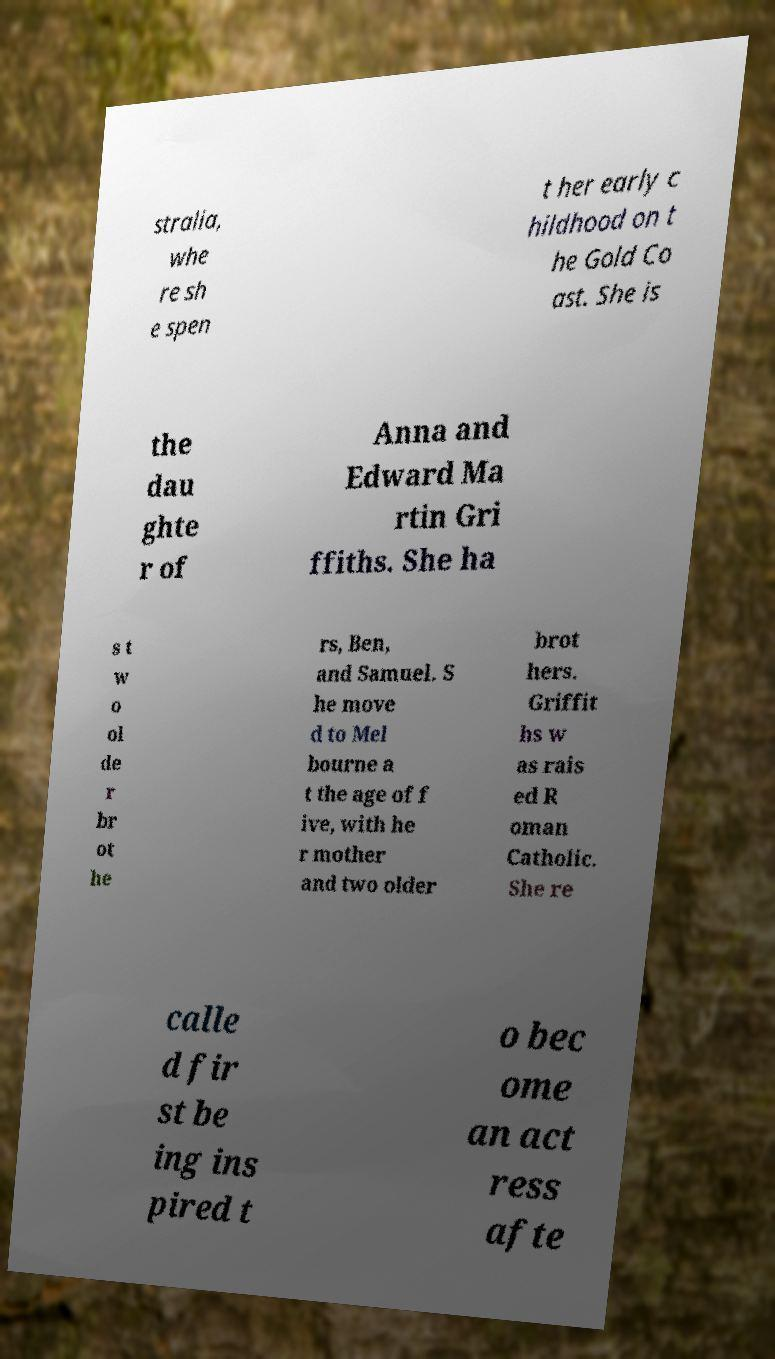Could you extract and type out the text from this image? stralia, whe re sh e spen t her early c hildhood on t he Gold Co ast. She is the dau ghte r of Anna and Edward Ma rtin Gri ffiths. She ha s t w o ol de r br ot he rs, Ben, and Samuel. S he move d to Mel bourne a t the age of f ive, with he r mother and two older brot hers. Griffit hs w as rais ed R oman Catholic. She re calle d fir st be ing ins pired t o bec ome an act ress afte 